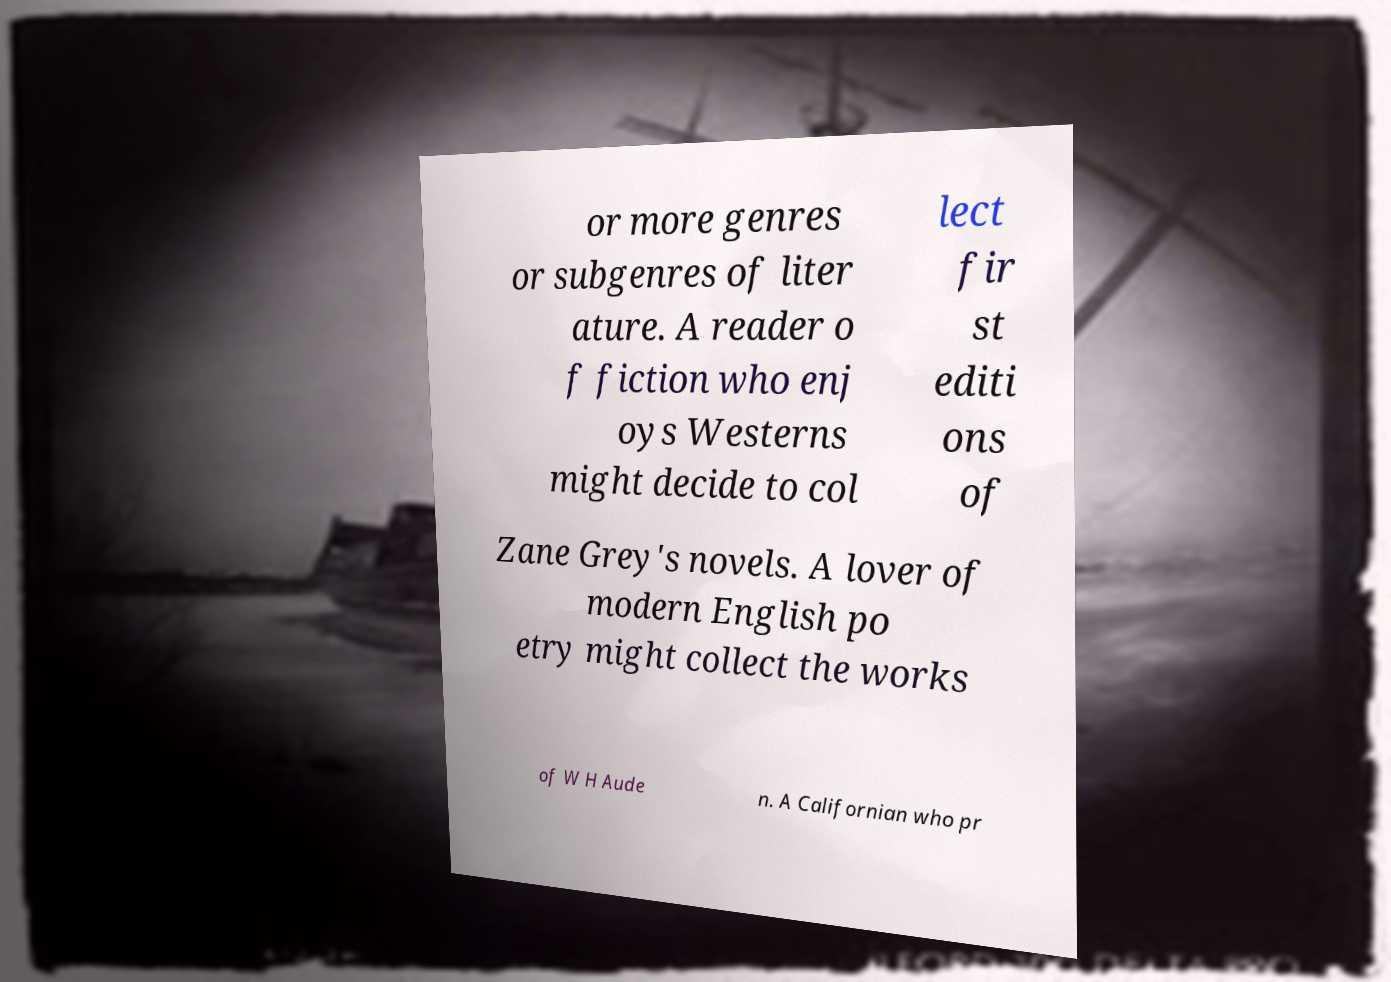There's text embedded in this image that I need extracted. Can you transcribe it verbatim? or more genres or subgenres of liter ature. A reader o f fiction who enj oys Westerns might decide to col lect fir st editi ons of Zane Grey's novels. A lover of modern English po etry might collect the works of W H Aude n. A Californian who pr 